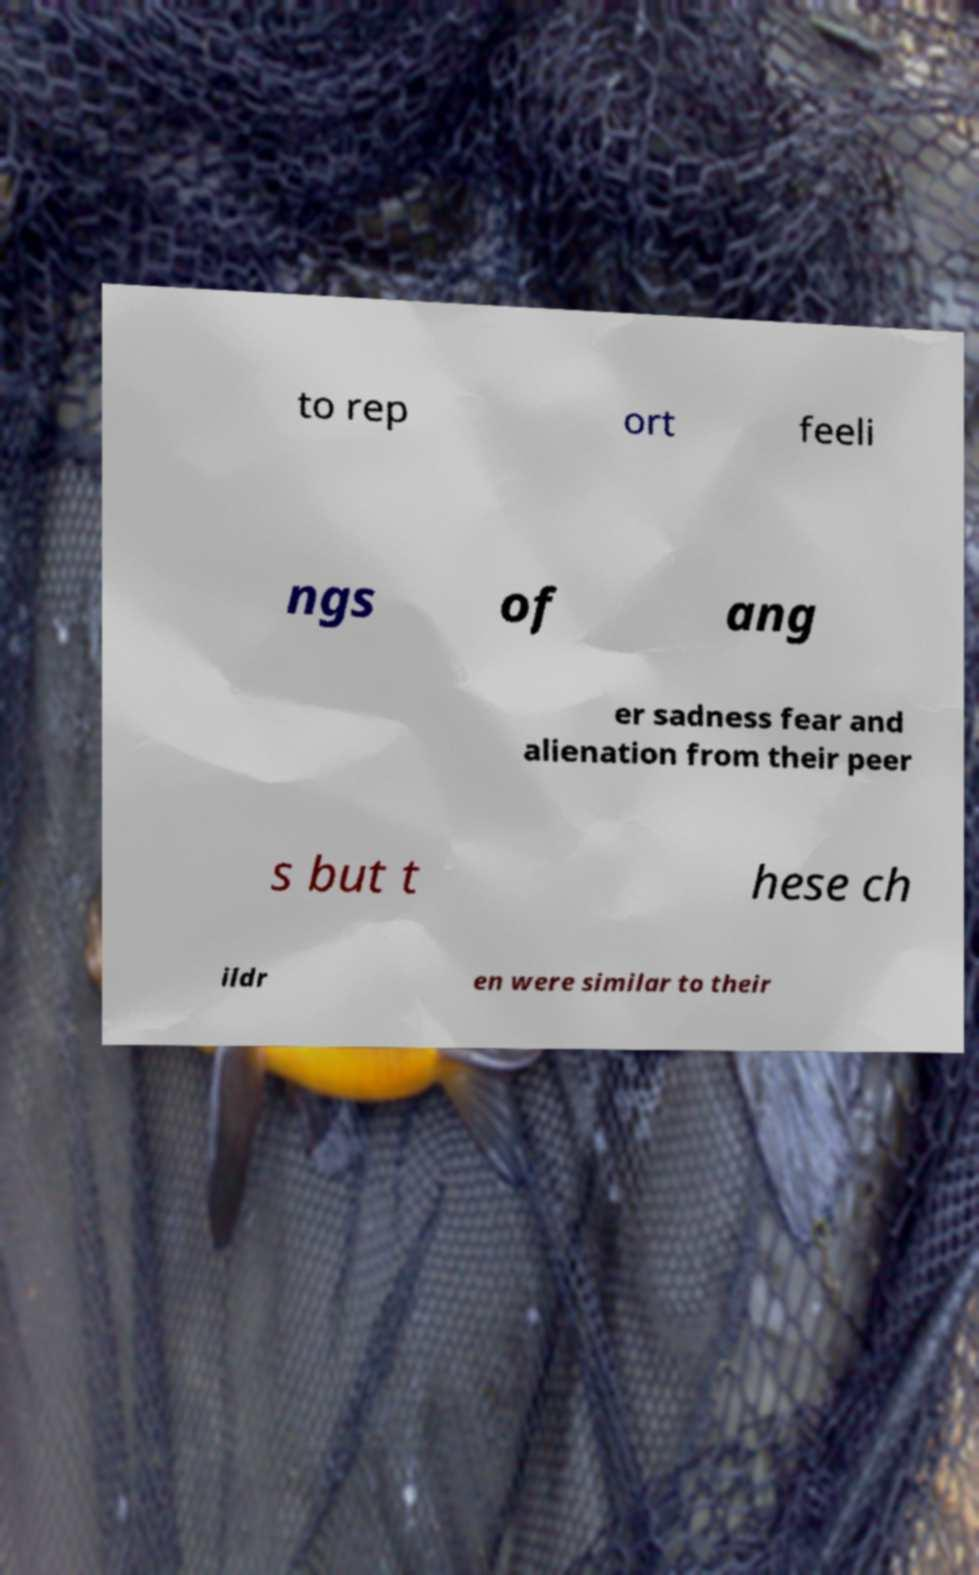Could you assist in decoding the text presented in this image and type it out clearly? to rep ort feeli ngs of ang er sadness fear and alienation from their peer s but t hese ch ildr en were similar to their 